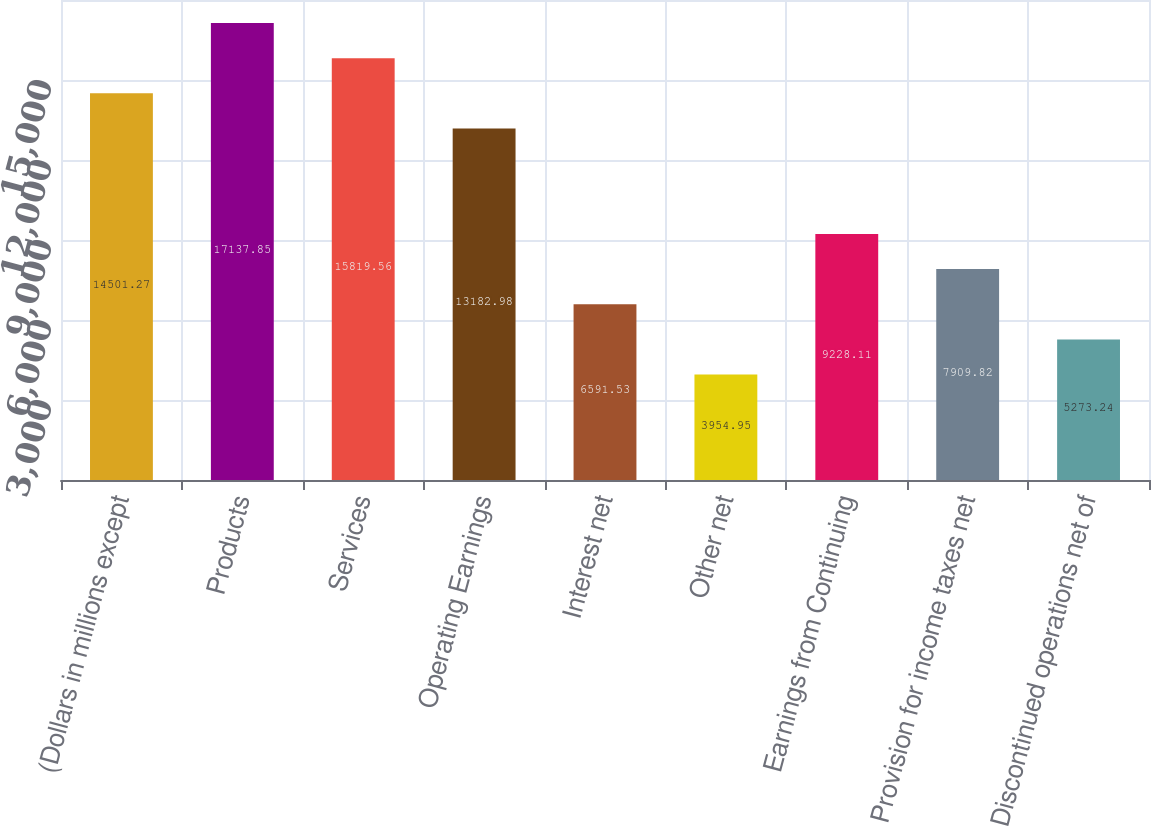Convert chart. <chart><loc_0><loc_0><loc_500><loc_500><bar_chart><fcel>(Dollars in millions except<fcel>Products<fcel>Services<fcel>Operating Earnings<fcel>Interest net<fcel>Other net<fcel>Earnings from Continuing<fcel>Provision for income taxes net<fcel>Discontinued operations net of<nl><fcel>14501.3<fcel>17137.8<fcel>15819.6<fcel>13183<fcel>6591.53<fcel>3954.95<fcel>9228.11<fcel>7909.82<fcel>5273.24<nl></chart> 